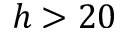<formula> <loc_0><loc_0><loc_500><loc_500>h > 2 0</formula> 